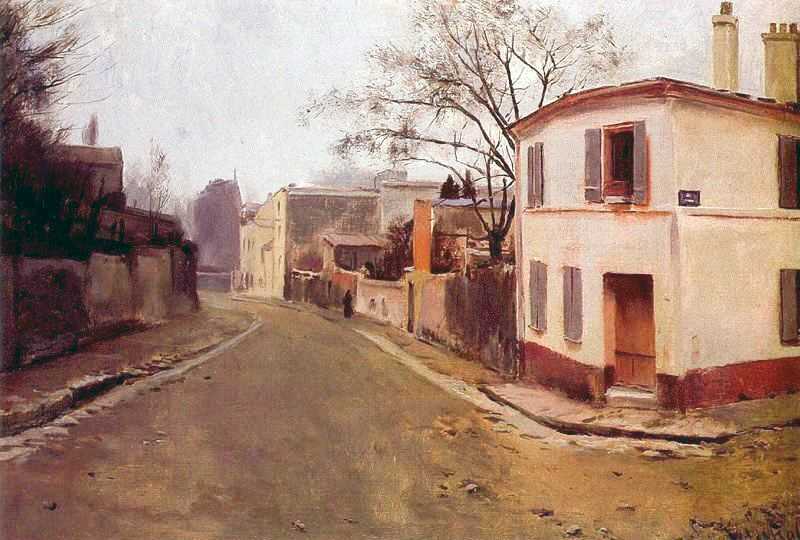How do you think the artist felt while painting this scene? The artist likely felt a deep sense of tranquility and reflection while painting this scene. The choice of serene, muted tones and the focus on a peaceful street suggests a contemplative mood. The artist might have been inspired by the quiet beauty of the town, cherishing the calm and simplicity that it offered. There could be an underlying feeling of nostalgia, as if the artist was capturing a moment from memory or longing for the peacefulness of a bygone era. The meticulous yet expressive brushstrokes indicate a desire to convey the essence of the scene, suggesting a profound appreciation and emotional connection to the subject. 